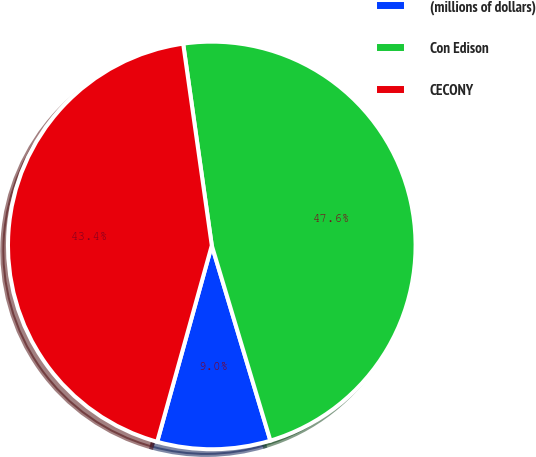Convert chart to OTSL. <chart><loc_0><loc_0><loc_500><loc_500><pie_chart><fcel>(millions of dollars)<fcel>Con Edison<fcel>CECONY<nl><fcel>8.96%<fcel>47.6%<fcel>43.44%<nl></chart> 